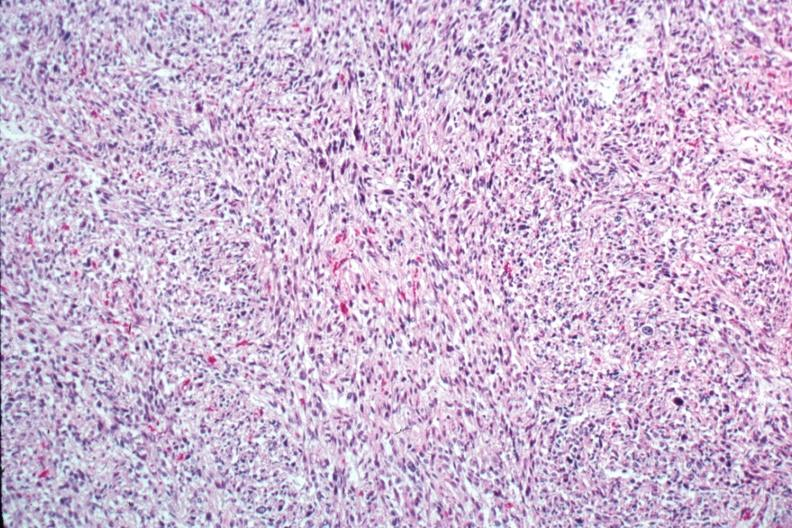s female reproductive present?
Answer the question using a single word or phrase. Yes 